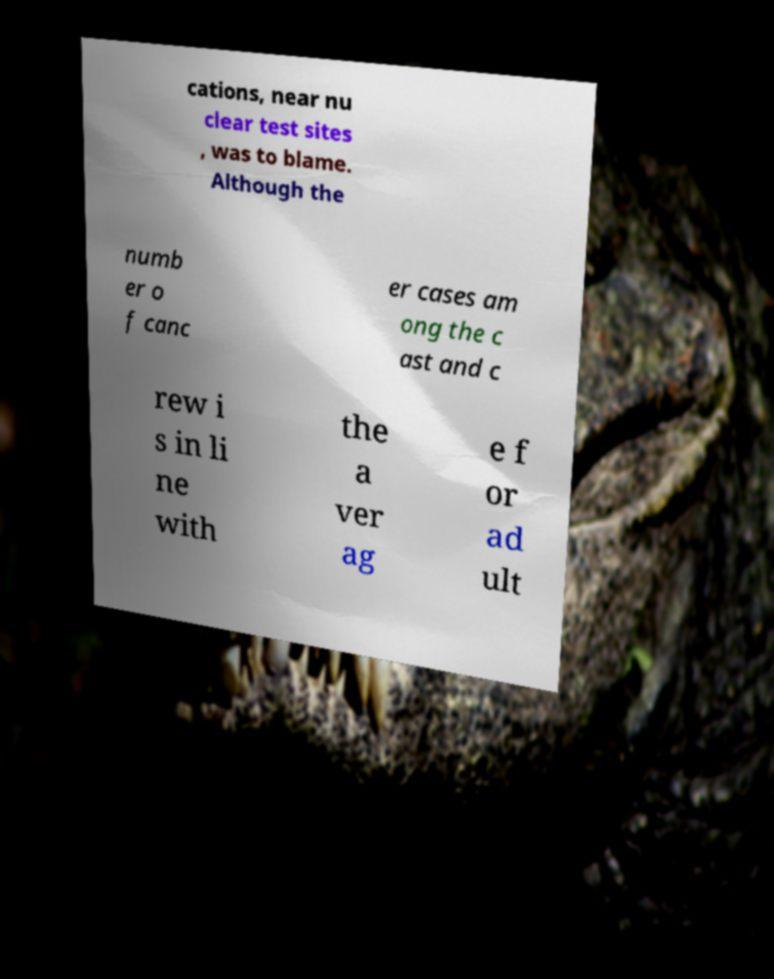Could you assist in decoding the text presented in this image and type it out clearly? cations, near nu clear test sites , was to blame. Although the numb er o f canc er cases am ong the c ast and c rew i s in li ne with the a ver ag e f or ad ult 